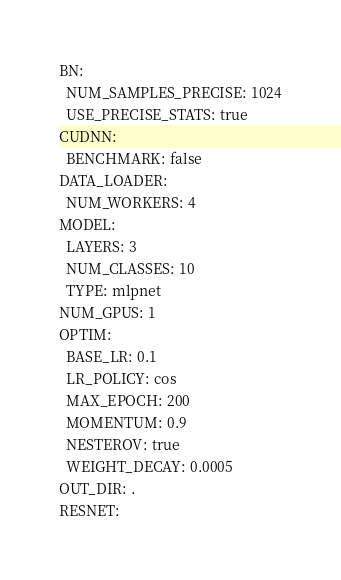Convert code to text. <code><loc_0><loc_0><loc_500><loc_500><_YAML_>BN:
  NUM_SAMPLES_PRECISE: 1024
  USE_PRECISE_STATS: true
CUDNN:
  BENCHMARK: false
DATA_LOADER:
  NUM_WORKERS: 4
MODEL:
  LAYERS: 3
  NUM_CLASSES: 10
  TYPE: mlpnet
NUM_GPUS: 1
OPTIM:
  BASE_LR: 0.1
  LR_POLICY: cos
  MAX_EPOCH: 200
  MOMENTUM: 0.9
  NESTEROV: true
  WEIGHT_DECAY: 0.0005
OUT_DIR: .
RESNET:</code> 